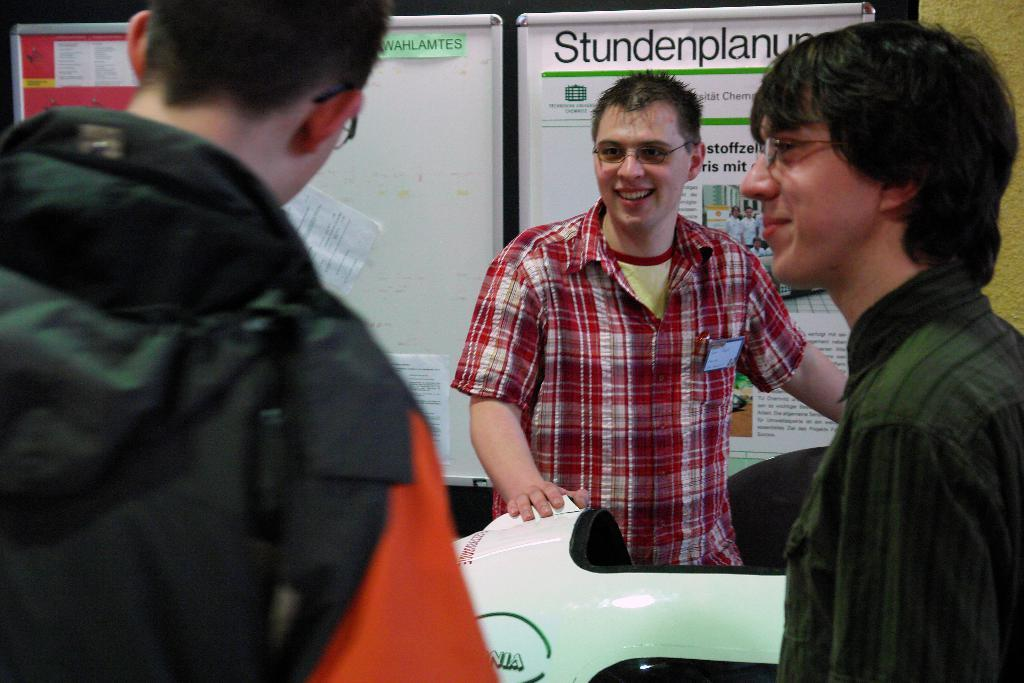How many people are in the image? There are people in the image, but the exact number is not specified. What can be observed about the clothing of the people in the image? The people are wearing different dress. What type of objects can be seen in the background of the image? There are two white boards and one red board in the background. Can you describe the color of the object in the front of the image? There is a white and black color object in the front. What type of authority is being exercised by the people in the image? There is no indication of any authority being exercised by the people in the image. Can you recite a verse from the red board in the image? There is no text or verse visible on the red board in the image. 